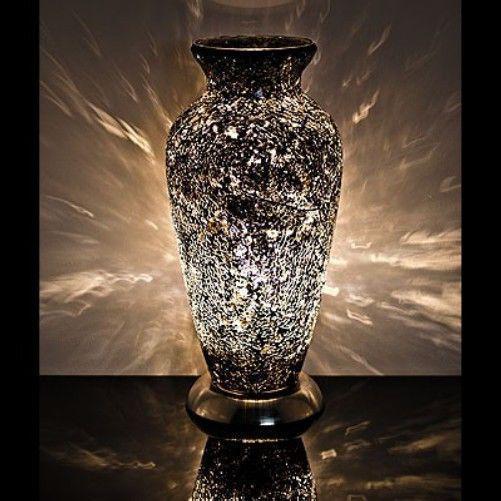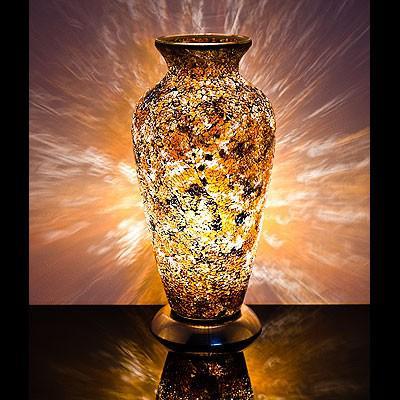The first image is the image on the left, the second image is the image on the right. Given the left and right images, does the statement "Both vases share the same shape." hold true? Answer yes or no. Yes. The first image is the image on the left, the second image is the image on the right. For the images shown, is this caption "In both images, rays of light in the background appear to eminate from the vase." true? Answer yes or no. Yes. 